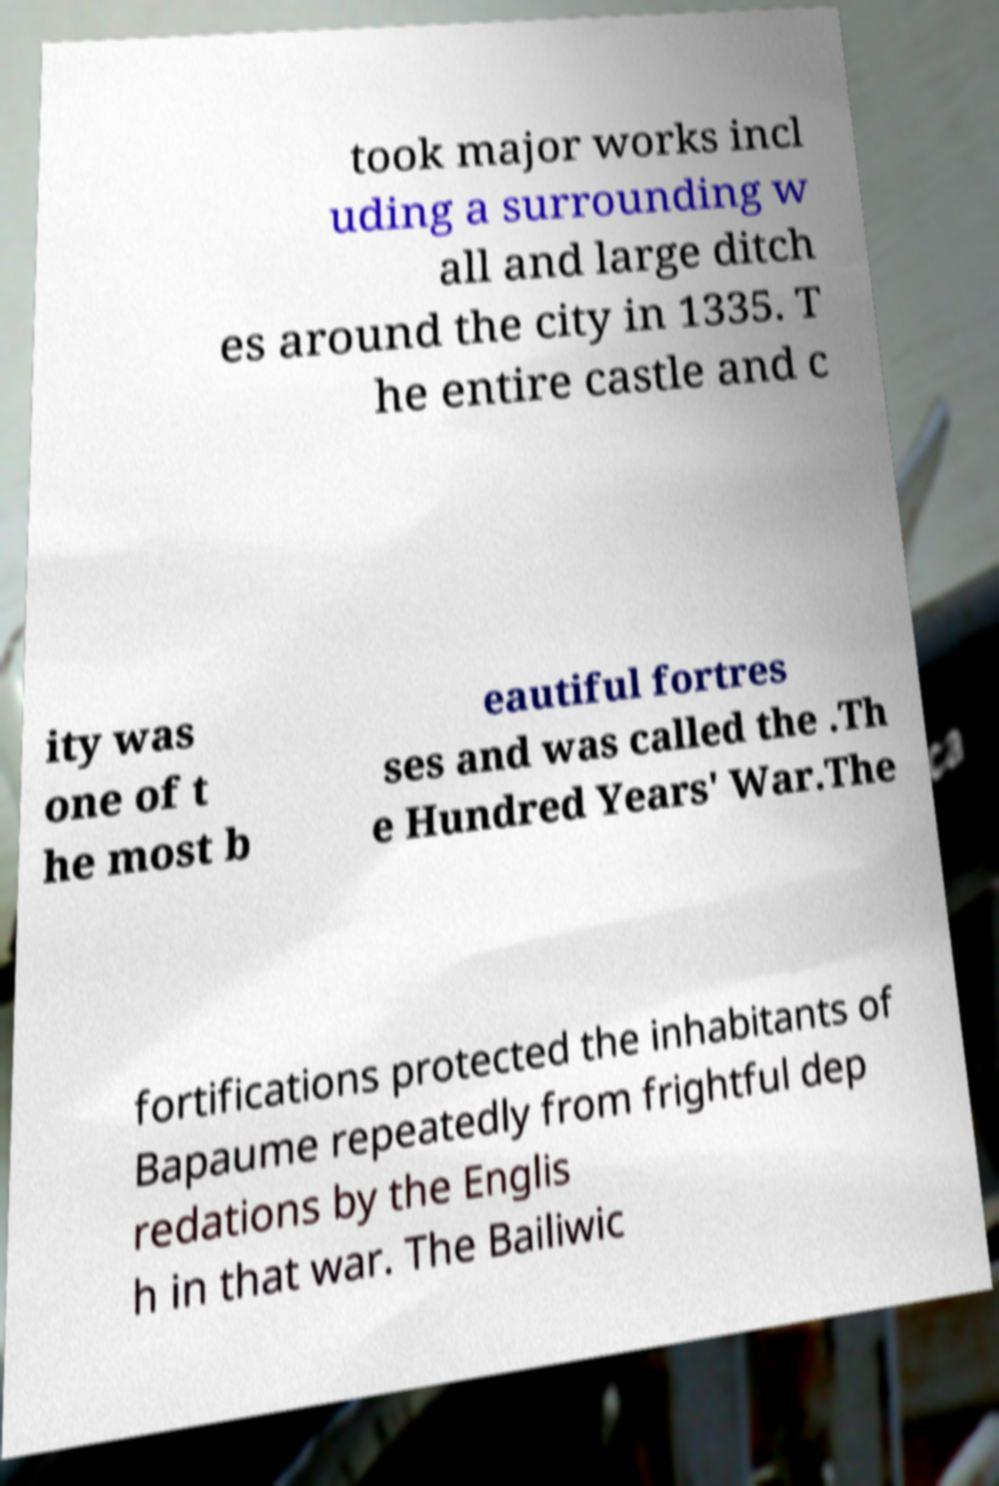What messages or text are displayed in this image? I need them in a readable, typed format. took major works incl uding a surrounding w all and large ditch es around the city in 1335. T he entire castle and c ity was one of t he most b eautiful fortres ses and was called the .Th e Hundred Years' War.The fortifications protected the inhabitants of Bapaume repeatedly from frightful dep redations by the Englis h in that war. The Bailiwic 